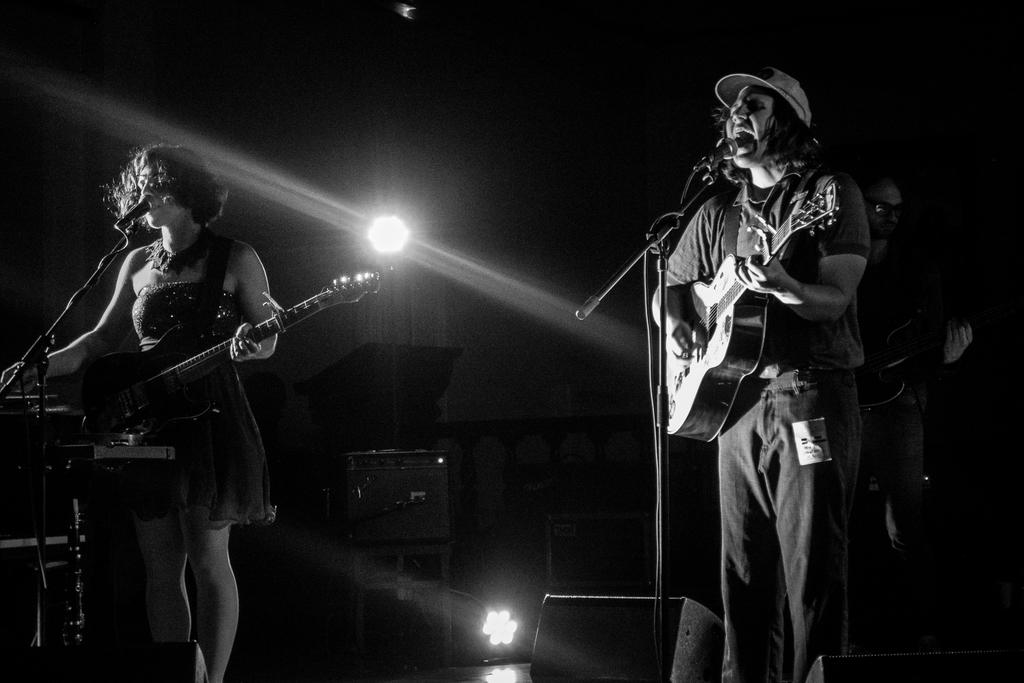How many people are in the image? There are three people in the image. What are the man and the woman doing in the image? Both the man and the woman are singing and playing guitars. What object is present in the image that is commonly used for amplifying sound? A microphone is present in the image. What is the other man in the image doing? The other man is standing and playing a guitar. Can you see a nest in the image? There is no nest present in the image. What type of laborer is depicted in the image? There are no laborers depicted in the image; it features people singing and playing musical instruments. 